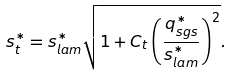Convert formula to latex. <formula><loc_0><loc_0><loc_500><loc_500>s _ { t } ^ { \ast } = s _ { l a m } ^ { \ast } \sqrt { 1 + C _ { t } \left ( \frac { q _ { s g s } ^ { \ast } } { s _ { l a m } ^ { \ast } } \right ) ^ { 2 } } .</formula> 